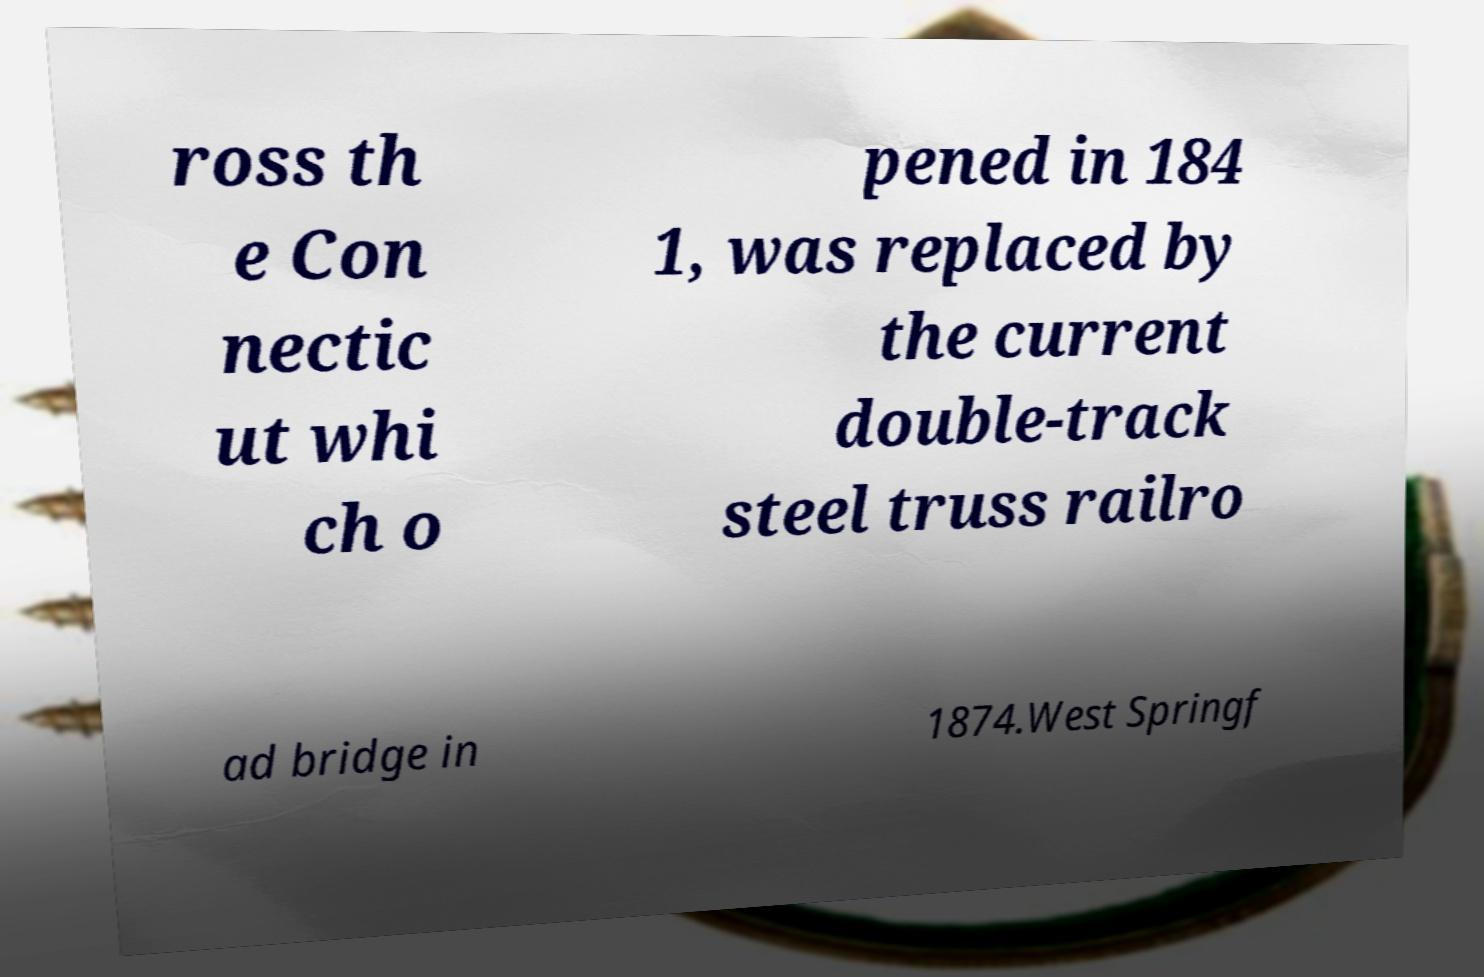Could you assist in decoding the text presented in this image and type it out clearly? ross th e Con nectic ut whi ch o pened in 184 1, was replaced by the current double-track steel truss railro ad bridge in 1874.West Springf 